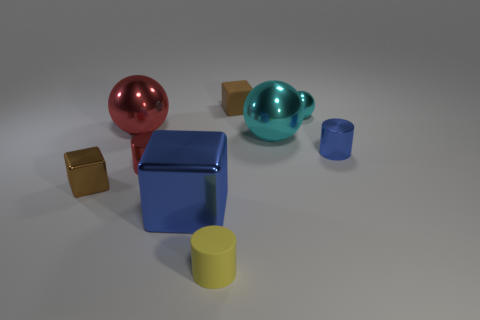Subtract all large blue cubes. How many cubes are left? 2 Add 1 matte cylinders. How many objects exist? 10 Subtract all cylinders. How many objects are left? 6 Add 6 small yellow cylinders. How many small yellow cylinders are left? 7 Add 7 purple spheres. How many purple spheres exist? 7 Subtract 0 cyan cylinders. How many objects are left? 9 Subtract all yellow rubber cylinders. Subtract all brown metal blocks. How many objects are left? 7 